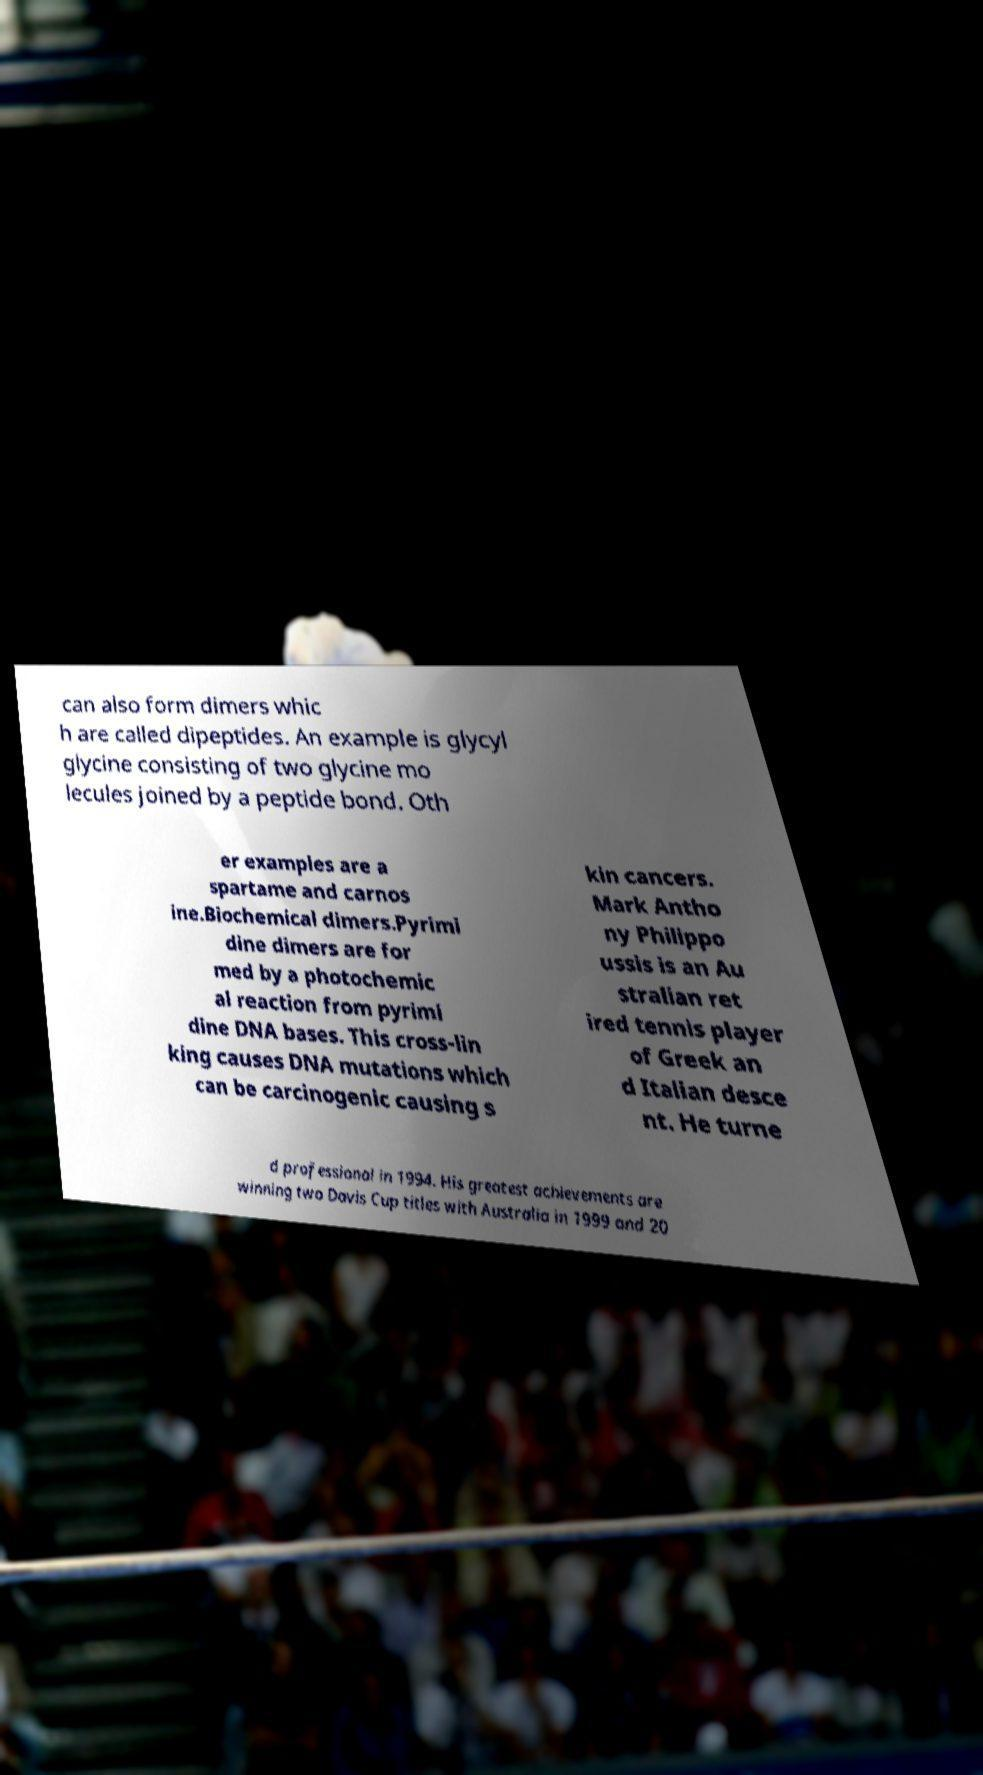Could you assist in decoding the text presented in this image and type it out clearly? can also form dimers whic h are called dipeptides. An example is glycyl glycine consisting of two glycine mo lecules joined by a peptide bond. Oth er examples are a spartame and carnos ine.Biochemical dimers.Pyrimi dine dimers are for med by a photochemic al reaction from pyrimi dine DNA bases. This cross-lin king causes DNA mutations which can be carcinogenic causing s kin cancers. Mark Antho ny Philippo ussis is an Au stralian ret ired tennis player of Greek an d Italian desce nt. He turne d professional in 1994. His greatest achievements are winning two Davis Cup titles with Australia in 1999 and 20 